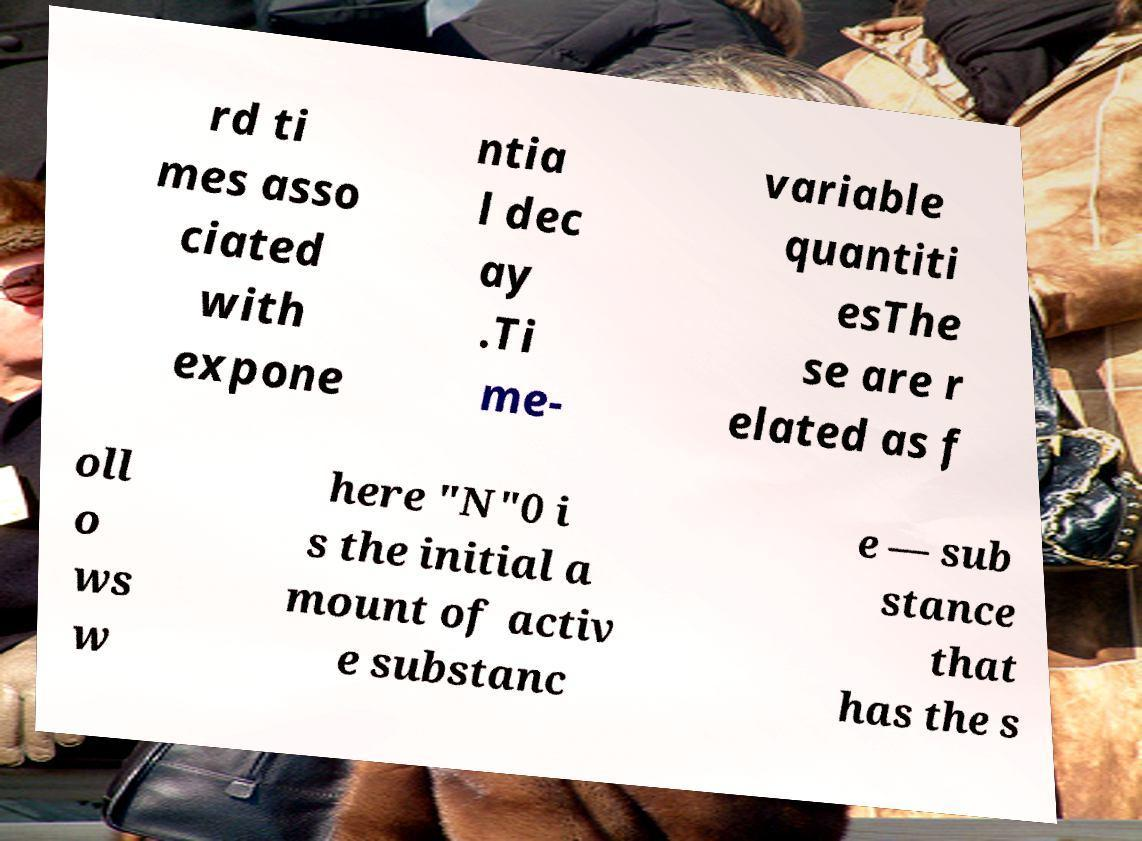Can you read and provide the text displayed in the image?This photo seems to have some interesting text. Can you extract and type it out for me? rd ti mes asso ciated with expone ntia l dec ay .Ti me- variable quantiti esThe se are r elated as f oll o ws w here "N"0 i s the initial a mount of activ e substanc e — sub stance that has the s 